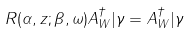Convert formula to latex. <formula><loc_0><loc_0><loc_500><loc_500>R ( \alpha , z ; \beta , \omega ) A _ { W } ^ { \dag } | \gamma = A _ { W } ^ { \dag } | \gamma</formula> 